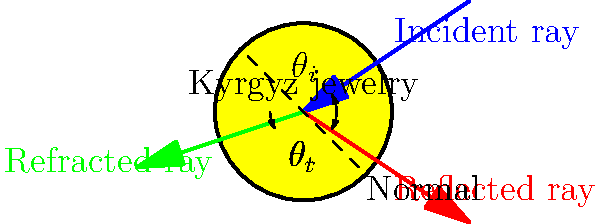In traditional Kyrgyz jewelry, light often interacts with precious metals and gemstones. Consider a light ray striking a polished gold surface of a Kyrgyz pendant at an angle of 30° to the normal. If the refractive index of gold is approximately 0.47 at the given wavelength, what is the angle of refraction for the transmitted light? To solve this problem, we'll use Snell's law, which describes the relationship between the angles of incidence and refraction for light passing through different media. The steps are as follows:

1. Identify the given information:
   - Angle of incidence, $\theta_i = 30°$
   - Refractive index of air, $n_1 \approx 1$ (assumed)
   - Refractive index of gold, $n_2 = 0.47$

2. Recall Snell's law: $n_1 \sin(\theta_1) = n_2 \sin(\theta_2)$

3. Rearrange Snell's law to solve for $\theta_2$ (angle of refraction):
   $\sin(\theta_2) = \frac{n_1}{n_2} \sin(\theta_1)$

4. Substitute the known values:
   $\sin(\theta_2) = \frac{1}{0.47} \sin(30°)$

5. Calculate:
   $\sin(\theta_2) = \frac{1}{0.47} \cdot 0.5 = 1.0638$

6. The $\sin(\theta_2)$ value is greater than 1, which is impossible for a real angle.

7. This result indicates that total internal reflection occurs, and there is no refracted ray entering the gold.

In this case, all light is reflected at the surface of the gold, which contributes to the bright, shiny appearance of traditional Kyrgyz gold jewelry.
Answer: Total internal reflection; no refraction occurs. 